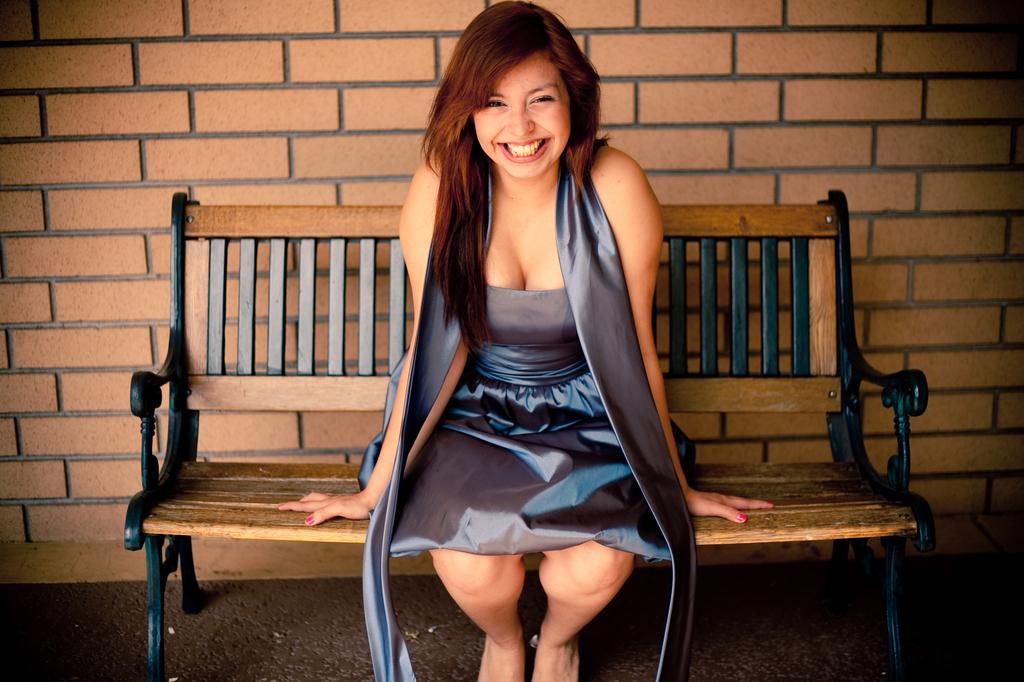What type of structure is visible in the image? There is a brick wall in the image. What is the woman in the image doing? The woman is sitting on a bench in the image. What year is depicted in the image? The provided facts do not mention any specific year, so it cannot be determined from the image. What type of soap is the woman using in the image? There is no soap present in the image; the woman is sitting on a bench. 